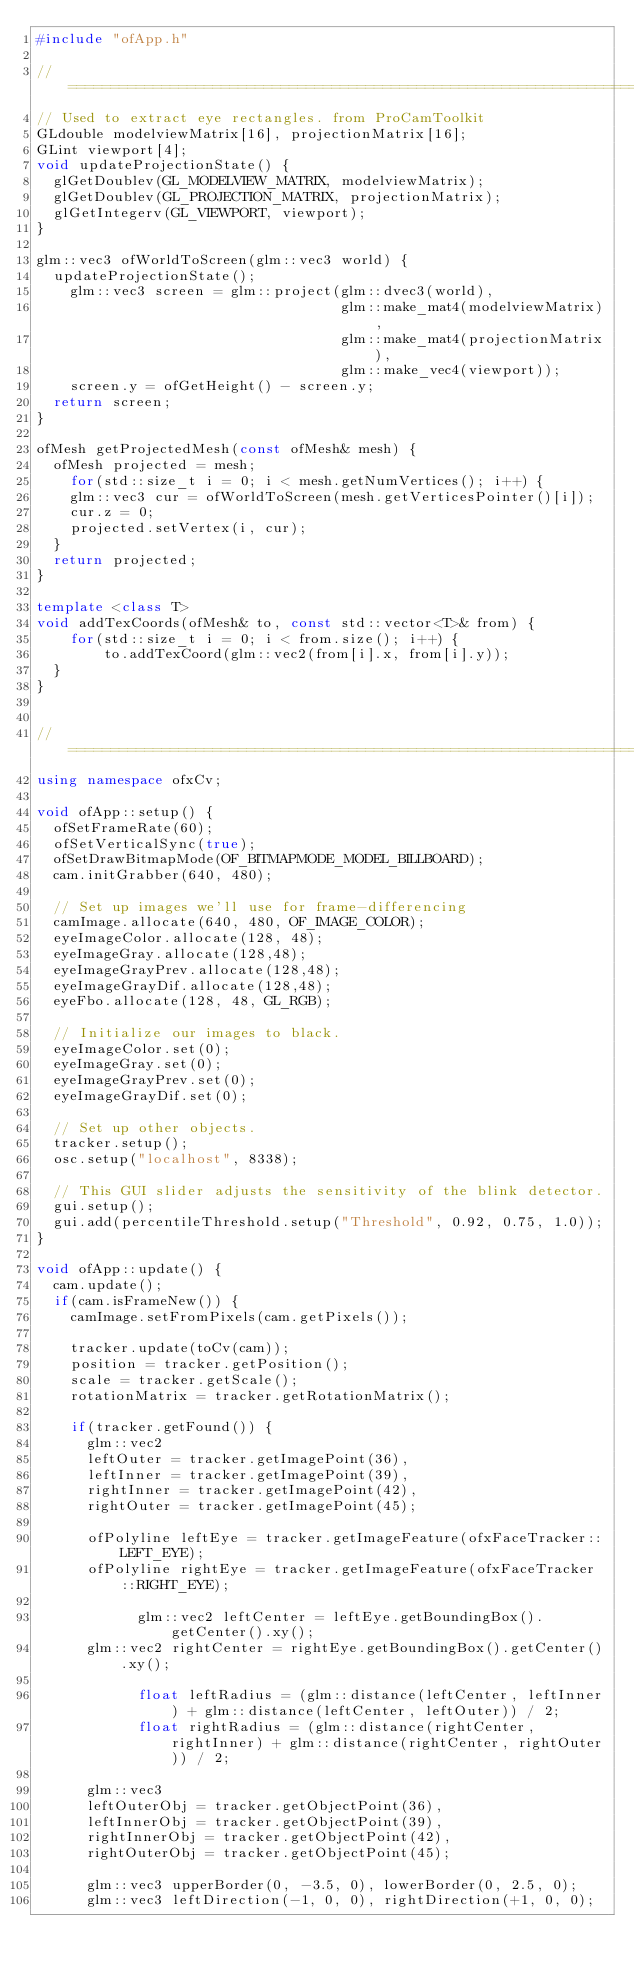Convert code to text. <code><loc_0><loc_0><loc_500><loc_500><_C++_>#include "ofApp.h"

//===================================================================
// Used to extract eye rectangles. from ProCamToolkit
GLdouble modelviewMatrix[16], projectionMatrix[16];
GLint viewport[4];
void updateProjectionState() {
	glGetDoublev(GL_MODELVIEW_MATRIX, modelviewMatrix);
	glGetDoublev(GL_PROJECTION_MATRIX, projectionMatrix);
	glGetIntegerv(GL_VIEWPORT, viewport);
}

glm::vec3 ofWorldToScreen(glm::vec3 world) {
	updateProjectionState();
    glm::vec3 screen = glm::project(glm::dvec3(world),
                                    glm::make_mat4(modelviewMatrix),
                                    glm::make_mat4(projectionMatrix),
                                    glm::make_vec4(viewport));
    screen.y = ofGetHeight() - screen.y;
	return screen;
}

ofMesh getProjectedMesh(const ofMesh& mesh) {
	ofMesh projected = mesh;
    for(std::size_t i = 0; i < mesh.getNumVertices(); i++) {
		glm::vec3 cur = ofWorldToScreen(mesh.getVerticesPointer()[i]);
		cur.z = 0;
		projected.setVertex(i, cur);
	}
	return projected;
}

template <class T>
void addTexCoords(ofMesh& to, const std::vector<T>& from) {
    for(std::size_t i = 0; i < from.size(); i++) {
        to.addTexCoord(glm::vec2(from[i].x, from[i].y));
	}
}


//===================================================================
using namespace ofxCv;

void ofApp::setup() {
	ofSetFrameRate(60);
	ofSetVerticalSync(true);
	ofSetDrawBitmapMode(OF_BITMAPMODE_MODEL_BILLBOARD);
	cam.initGrabber(640, 480);
	
	// Set up images we'll use for frame-differencing
	camImage.allocate(640, 480, OF_IMAGE_COLOR);
	eyeImageColor.allocate(128, 48);
	eyeImageGray.allocate(128,48);
	eyeImageGrayPrev.allocate(128,48);
	eyeImageGrayDif.allocate(128,48);
	eyeFbo.allocate(128, 48, GL_RGB);
	
	// Initialize our images to black.
	eyeImageColor.set(0);
	eyeImageGray.set(0);
	eyeImageGrayPrev.set(0);
	eyeImageGrayDif.set(0);

	// Set up other objects.
	tracker.setup();
	osc.setup("localhost", 8338);
	
	// This GUI slider adjusts the sensitivity of the blink detector.
	gui.setup();
	gui.add(percentileThreshold.setup("Threshold", 0.92, 0.75, 1.0));
}

void ofApp::update() {
	cam.update();
	if(cam.isFrameNew()) {
		camImage.setFromPixels(cam.getPixels());
		
		tracker.update(toCv(cam));
		position = tracker.getPosition();
		scale = tracker.getScale();
		rotationMatrix = tracker.getRotationMatrix();

		if(tracker.getFound()) {
			glm::vec2
			leftOuter = tracker.getImagePoint(36),
			leftInner = tracker.getImagePoint(39),
			rightInner = tracker.getImagePoint(42),
			rightOuter = tracker.getImagePoint(45);

			ofPolyline leftEye = tracker.getImageFeature(ofxFaceTracker::LEFT_EYE);
			ofPolyline rightEye = tracker.getImageFeature(ofxFaceTracker::RIGHT_EYE);

            glm::vec2 leftCenter = leftEye.getBoundingBox().getCenter().xy();
			glm::vec2 rightCenter = rightEye.getBoundingBox().getCenter().xy();

            float leftRadius = (glm::distance(leftCenter, leftInner) + glm::distance(leftCenter, leftOuter)) / 2;
            float rightRadius = (glm::distance(rightCenter, rightInner) + glm::distance(rightCenter, rightOuter)) / 2;

			glm::vec3
			leftOuterObj = tracker.getObjectPoint(36),
			leftInnerObj = tracker.getObjectPoint(39),
			rightInnerObj = tracker.getObjectPoint(42),
			rightOuterObj = tracker.getObjectPoint(45);

			glm::vec3 upperBorder(0, -3.5, 0), lowerBorder(0, 2.5, 0);
			glm::vec3 leftDirection(-1, 0, 0), rightDirection(+1, 0, 0);</code> 